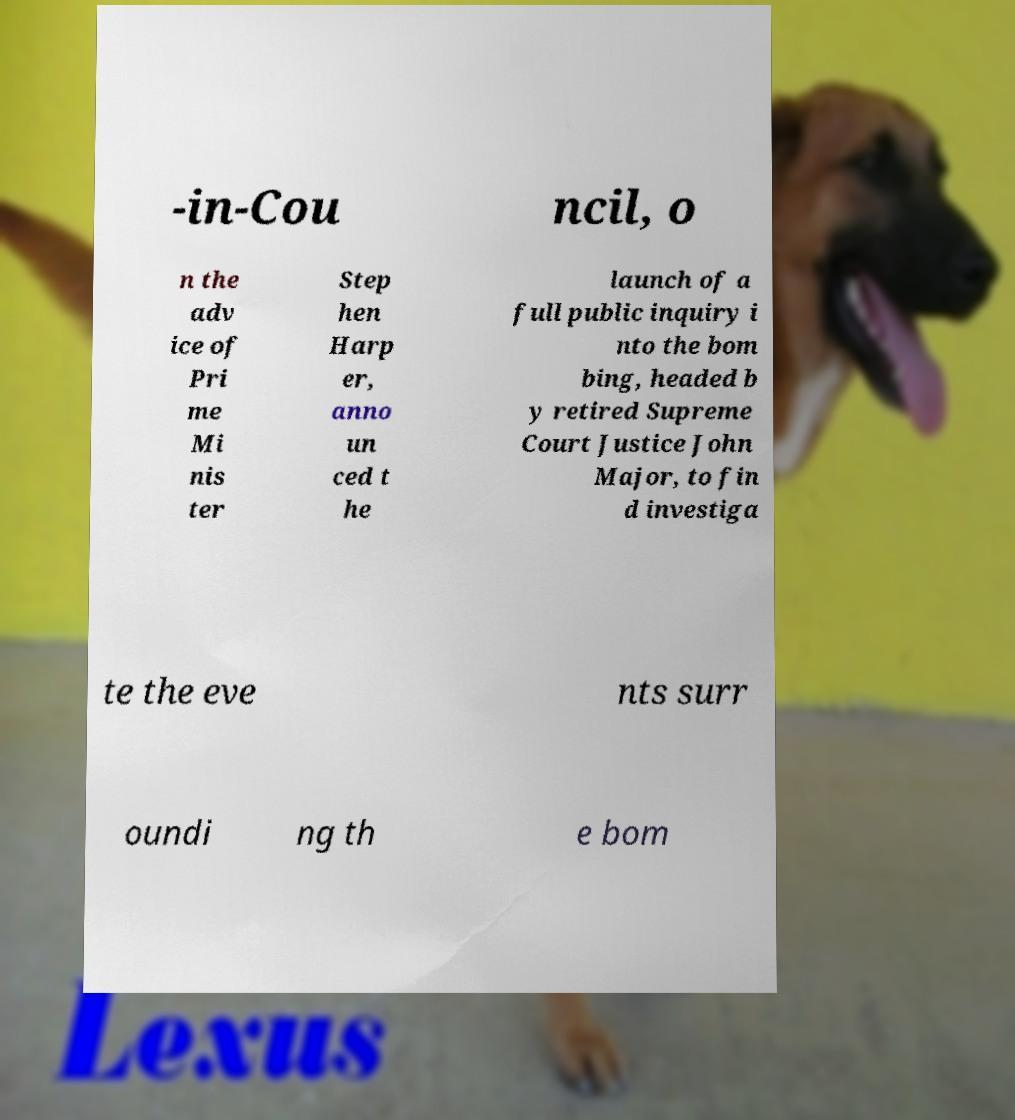Please identify and transcribe the text found in this image. -in-Cou ncil, o n the adv ice of Pri me Mi nis ter Step hen Harp er, anno un ced t he launch of a full public inquiry i nto the bom bing, headed b y retired Supreme Court Justice John Major, to fin d investiga te the eve nts surr oundi ng th e bom 